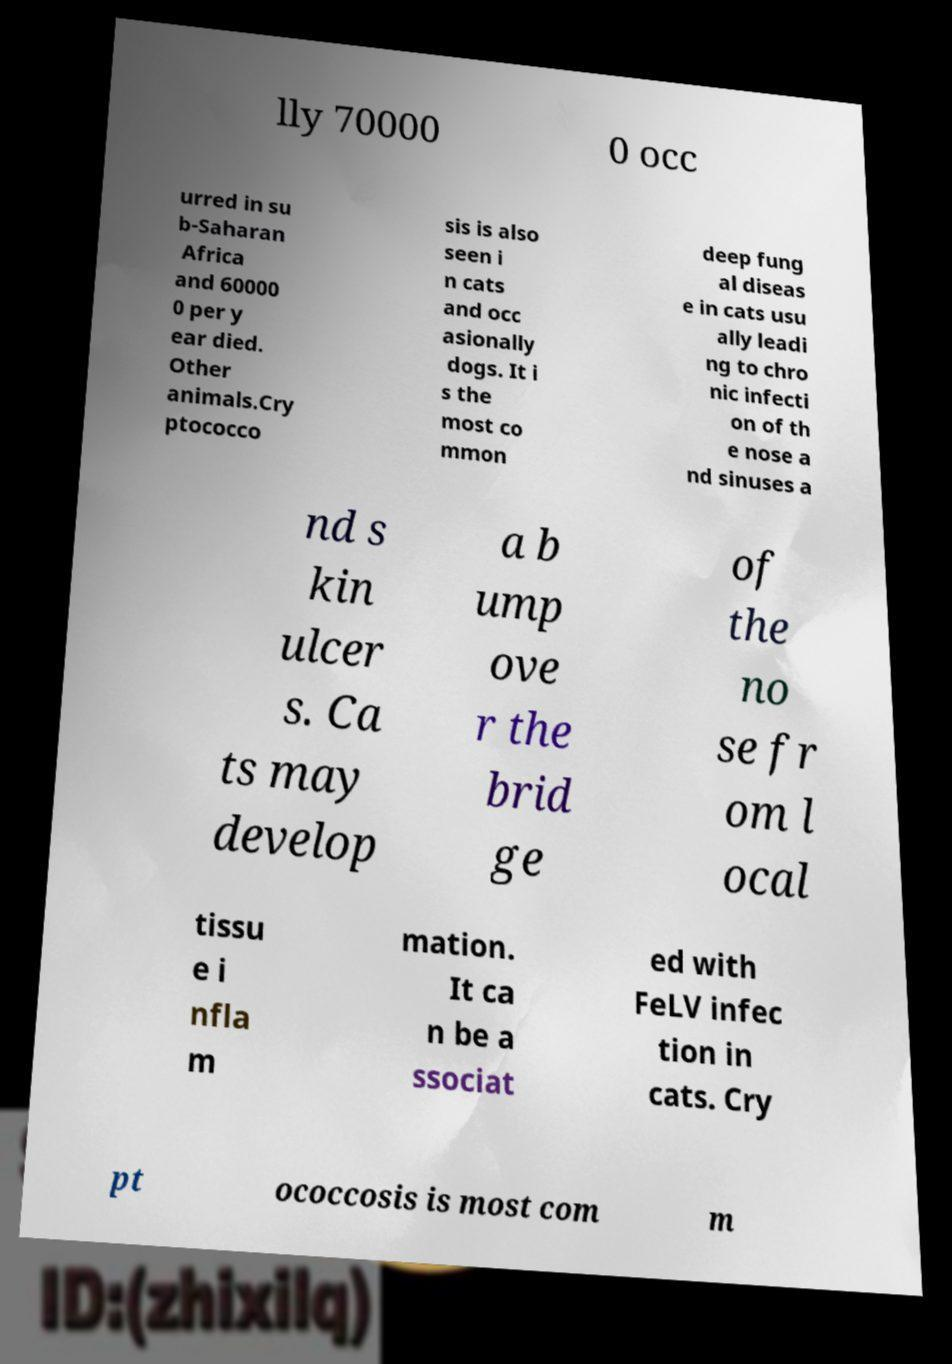For documentation purposes, I need the text within this image transcribed. Could you provide that? lly 70000 0 occ urred in su b-Saharan Africa and 60000 0 per y ear died. Other animals.Cry ptococco sis is also seen i n cats and occ asionally dogs. It i s the most co mmon deep fung al diseas e in cats usu ally leadi ng to chro nic infecti on of th e nose a nd sinuses a nd s kin ulcer s. Ca ts may develop a b ump ove r the brid ge of the no se fr om l ocal tissu e i nfla m mation. It ca n be a ssociat ed with FeLV infec tion in cats. Cry pt ococcosis is most com m 